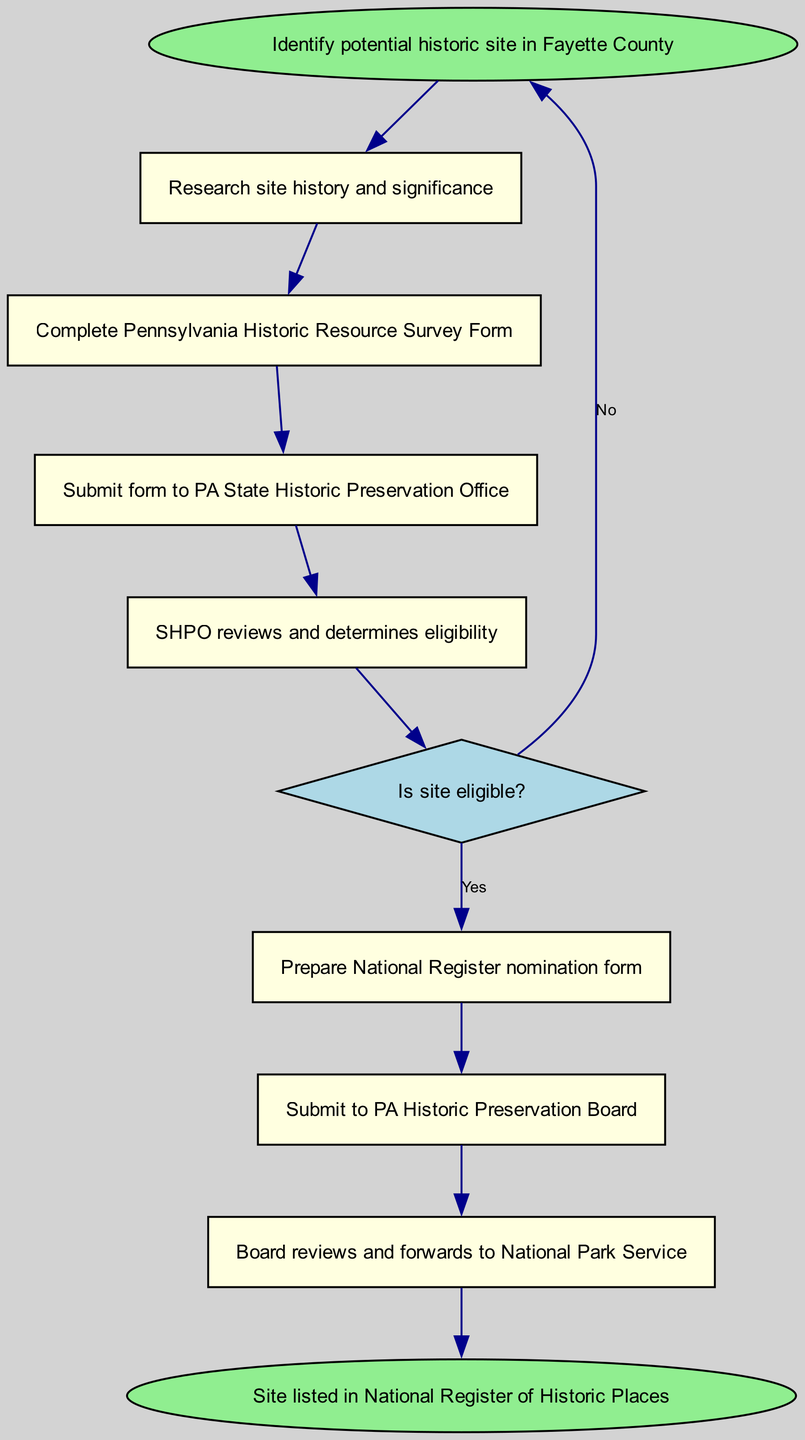What is the first step in the workflow? The first step is represented by the starting node labeled "Identify potential historic site in Fayette County." Therefore, the answer is found directly from the first element in the flow chart.
Answer: Identify potential historic site in Fayette County How many steps are there before submission to the PA State Historic Preservation Office? To find this, we look at the steps leading up to the submission node ("Submit form to PA State Historic Preservation Office"). The steps are: identify potential site, research site history, complete survey form — a total of three steps.
Answer: 3 What action occurs if the site is not eligible? According to the flow chart, if the decision is "No" regarding site eligibility, the flow returns to the "Identify potential historic site in Fayette County" node, indicating that further actions may be started again.
Answer: Identify potential historic site in Fayette County What document needs to be prepared after the eligibility decision is confirmed as "Yes"? Once eligibility is determined as "Yes," the next step in the flow chart is to "Prepare National Register nomination form." Hence, this document is what needs to be prepared at that stage.
Answer: Prepare National Register nomination form What does the PA Historic Preservation Board do after receiving the nomination? From the flow chart, after the nomination form is submitted to the PA Historic Preservation Board, the next action they take is to review it and forward the information to the National Park Service, as indicated in the connected nodes.
Answer: Reviews and forwards to National Park Service What is the endpoint of the workflow? The endpoint of this workflow is represented by the final node labeled "Site listed in National Register of Historic Places," which indicates the completion of the entire process.
Answer: Site listed in National Register of Historic Places 